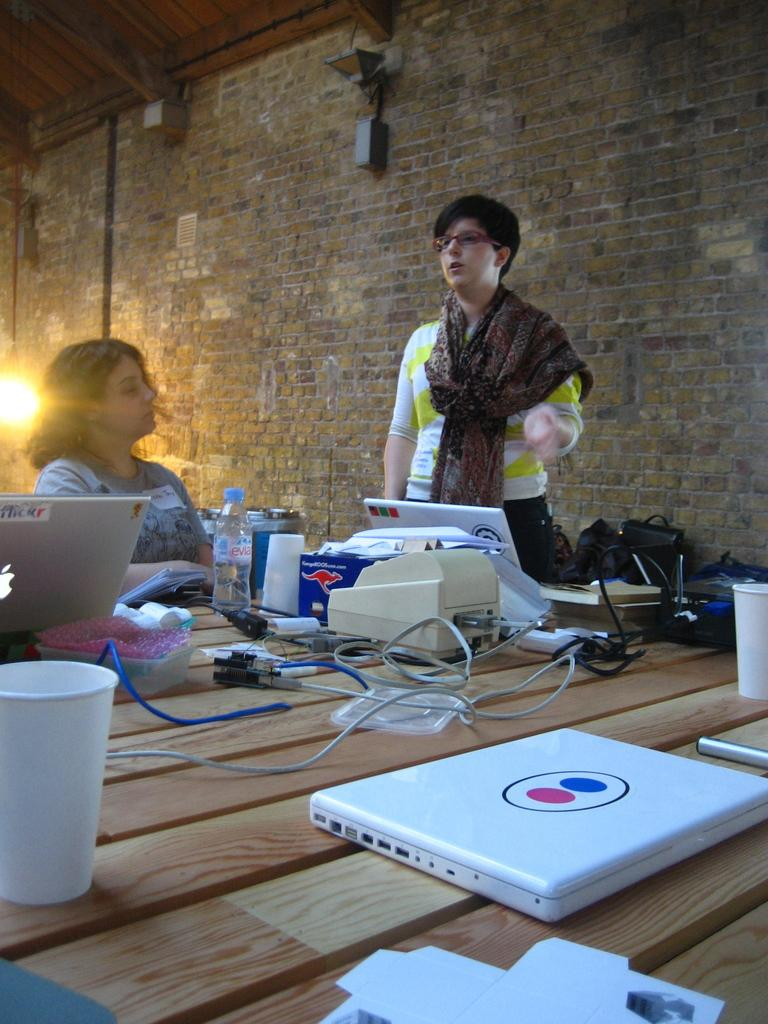How many people are in the image? There are two people in the image, one standing and one sitting. What is on the table in the image? There is a laptop, a cable, a bottle, and other things on the table. What is the person sitting doing? The person sitting is likely using the laptop, as it is on the table in front of them. What can be seen in the background of the image? There is a wall in the background of the image. What type of magic is being performed by the person standing in the image? There is no magic being performed in the image; it is a person standing next to a table with a laptop and other objects. What time of day is it during recess in the image? There is no indication of a recess or a specific time of day in the image. 